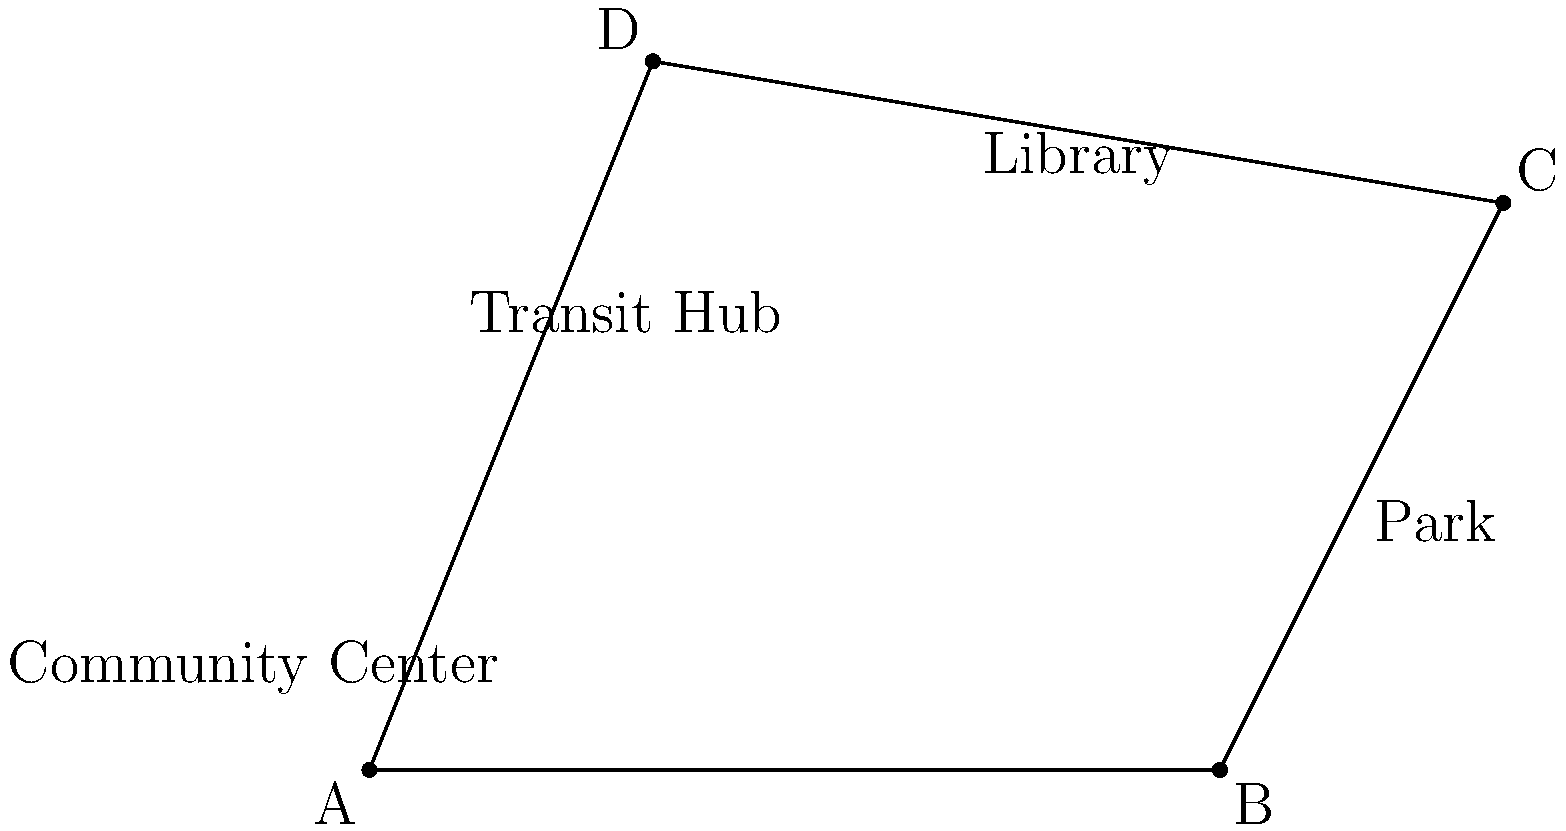As part of an urban development project in Minneapolis, four key locations are identified: a community center (A), a park (B), a library (C), and a transit hub (D). The coordinates of these locations on a city map are A(0,0), B(6,0), C(8,4), and D(2,5), where each unit represents 100 meters. What is the total area, in square meters, of the polygon formed by connecting these four locations? To find the area of the polygon ABCD, we can use the Shoelace formula (also known as the surveyor's formula). The steps are as follows:

1) The Shoelace formula for a quadrilateral with vertices $(x_1, y_1)$, $(x_2, y_2)$, $(x_3, y_3)$, and $(x_4, y_4)$ is:

   Area = $\frac{1}{2}|x_1y_2 + x_2y_3 + x_3y_4 + x_4y_1 - y_1x_2 - y_2x_3 - y_3x_4 - y_4x_1|$

2) Substitute the given coordinates:
   A(0,0), B(6,0), C(8,4), D(2,5)

3) Apply the formula:
   Area = $\frac{1}{2}|(0 \cdot 0 + 6 \cdot 4 + 8 \cdot 5 + 2 \cdot 0) - (0 \cdot 6 + 0 \cdot 8 + 4 \cdot 2 + 5 \cdot 0)|$

4) Simplify:
   Area = $\frac{1}{2}|(0 + 24 + 40 + 0) - (0 + 0 + 8 + 0)|$
   Area = $\frac{1}{2}|64 - 8|$
   Area = $\frac{1}{2} \cdot 56$
   Area = 28

5) Since each unit represents 100 meters, we need to multiply the result by $100^2 = 10,000$ to get the area in square meters:

   Area = $28 \cdot 10,000 = 280,000$ square meters
Answer: 280,000 square meters 